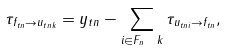Convert formula to latex. <formula><loc_0><loc_0><loc_500><loc_500>\tau _ { f _ { t n } \rightarrow u _ { t n k } } = y _ { t n } - \sum _ { i \in F _ { n } \ k } \tau _ { u _ { t n i } \rightarrow f _ { t n } } ,</formula> 